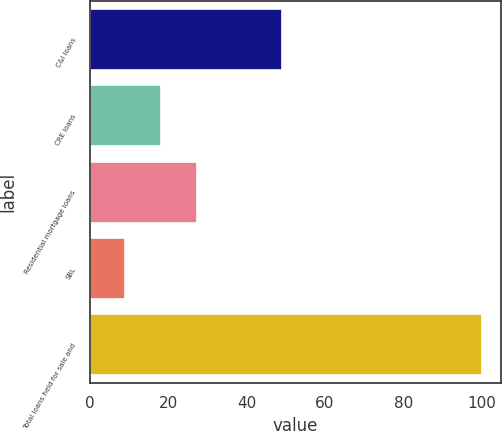<chart> <loc_0><loc_0><loc_500><loc_500><bar_chart><fcel>C&I loans<fcel>CRE loans<fcel>Residential mortgage loans<fcel>SBL<fcel>Total loans held for sale and<nl><fcel>49<fcel>18.1<fcel>27.2<fcel>9<fcel>100<nl></chart> 